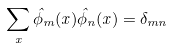<formula> <loc_0><loc_0><loc_500><loc_500>\sum _ { x } \hat { \phi } _ { m } ( x ) \hat { \phi } _ { n } ( x ) = \delta _ { m n }</formula> 